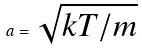<formula> <loc_0><loc_0><loc_500><loc_500>a = \sqrt { k T / m }</formula> 